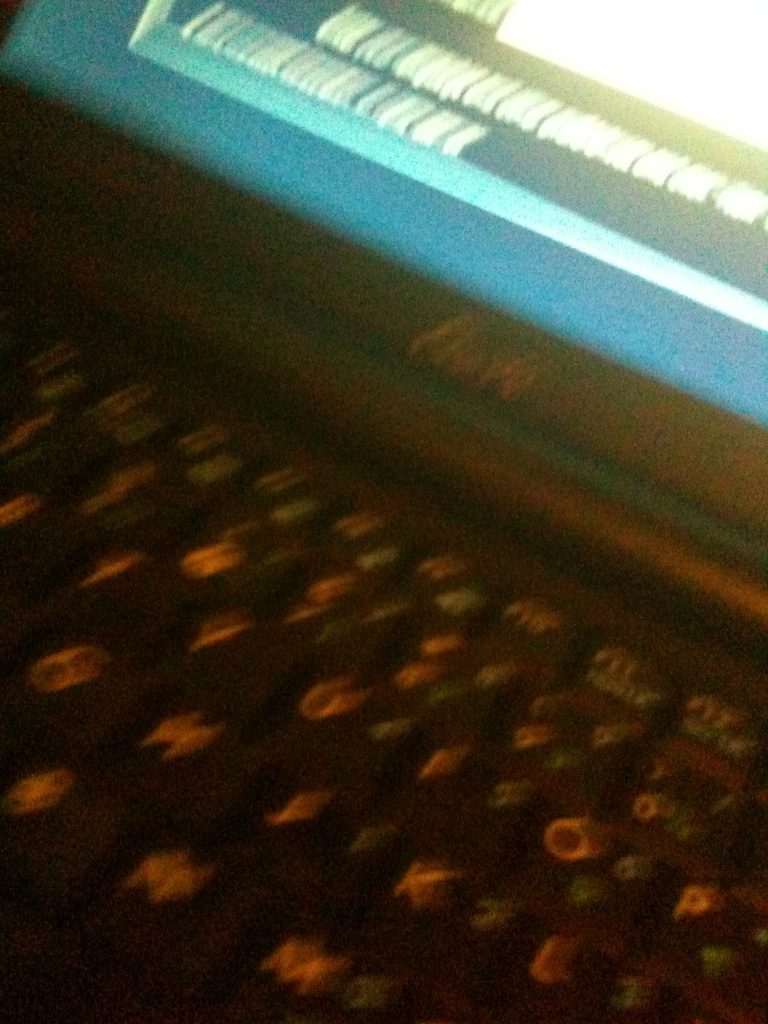Can you guess why this photo might have been taken? The photo might have been taken to document the setup or condition of the keyboard, possibly for technical support or personal reference. The quality suggests a quick, possibly urgent capture rather than a planned photograph. What might improve the quality of future photos like this? Using a camera with better low-light performance or adding more ambient light could greatly enhance photo quality. Employing a steady hand or a tripod to avoid blurring, and adjusting the focus settings on the camera could also help. 